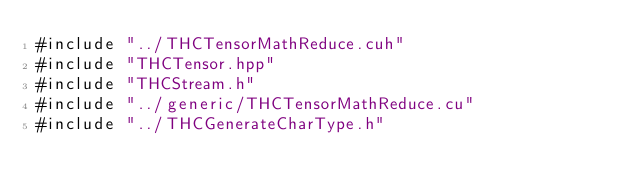<code> <loc_0><loc_0><loc_500><loc_500><_Cuda_>#include "../THCTensorMathReduce.cuh"
#include "THCTensor.hpp"
#include "THCStream.h"
#include "../generic/THCTensorMathReduce.cu"
#include "../THCGenerateCharType.h"
</code> 